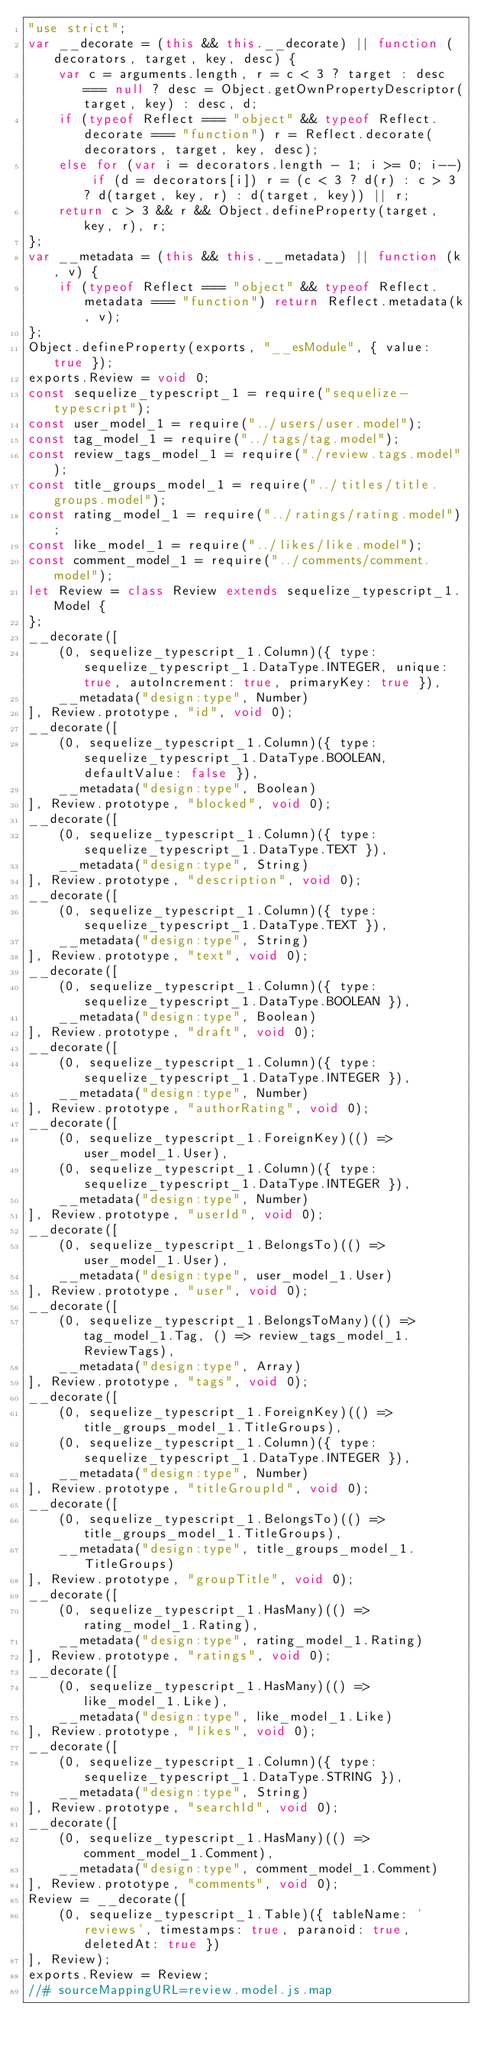<code> <loc_0><loc_0><loc_500><loc_500><_JavaScript_>"use strict";
var __decorate = (this && this.__decorate) || function (decorators, target, key, desc) {
    var c = arguments.length, r = c < 3 ? target : desc === null ? desc = Object.getOwnPropertyDescriptor(target, key) : desc, d;
    if (typeof Reflect === "object" && typeof Reflect.decorate === "function") r = Reflect.decorate(decorators, target, key, desc);
    else for (var i = decorators.length - 1; i >= 0; i--) if (d = decorators[i]) r = (c < 3 ? d(r) : c > 3 ? d(target, key, r) : d(target, key)) || r;
    return c > 3 && r && Object.defineProperty(target, key, r), r;
};
var __metadata = (this && this.__metadata) || function (k, v) {
    if (typeof Reflect === "object" && typeof Reflect.metadata === "function") return Reflect.metadata(k, v);
};
Object.defineProperty(exports, "__esModule", { value: true });
exports.Review = void 0;
const sequelize_typescript_1 = require("sequelize-typescript");
const user_model_1 = require("../users/user.model");
const tag_model_1 = require("../tags/tag.model");
const review_tags_model_1 = require("./review.tags.model");
const title_groups_model_1 = require("../titles/title.groups.model");
const rating_model_1 = require("../ratings/rating.model");
const like_model_1 = require("../likes/like.model");
const comment_model_1 = require("../comments/comment.model");
let Review = class Review extends sequelize_typescript_1.Model {
};
__decorate([
    (0, sequelize_typescript_1.Column)({ type: sequelize_typescript_1.DataType.INTEGER, unique: true, autoIncrement: true, primaryKey: true }),
    __metadata("design:type", Number)
], Review.prototype, "id", void 0);
__decorate([
    (0, sequelize_typescript_1.Column)({ type: sequelize_typescript_1.DataType.BOOLEAN, defaultValue: false }),
    __metadata("design:type", Boolean)
], Review.prototype, "blocked", void 0);
__decorate([
    (0, sequelize_typescript_1.Column)({ type: sequelize_typescript_1.DataType.TEXT }),
    __metadata("design:type", String)
], Review.prototype, "description", void 0);
__decorate([
    (0, sequelize_typescript_1.Column)({ type: sequelize_typescript_1.DataType.TEXT }),
    __metadata("design:type", String)
], Review.prototype, "text", void 0);
__decorate([
    (0, sequelize_typescript_1.Column)({ type: sequelize_typescript_1.DataType.BOOLEAN }),
    __metadata("design:type", Boolean)
], Review.prototype, "draft", void 0);
__decorate([
    (0, sequelize_typescript_1.Column)({ type: sequelize_typescript_1.DataType.INTEGER }),
    __metadata("design:type", Number)
], Review.prototype, "authorRating", void 0);
__decorate([
    (0, sequelize_typescript_1.ForeignKey)(() => user_model_1.User),
    (0, sequelize_typescript_1.Column)({ type: sequelize_typescript_1.DataType.INTEGER }),
    __metadata("design:type", Number)
], Review.prototype, "userId", void 0);
__decorate([
    (0, sequelize_typescript_1.BelongsTo)(() => user_model_1.User),
    __metadata("design:type", user_model_1.User)
], Review.prototype, "user", void 0);
__decorate([
    (0, sequelize_typescript_1.BelongsToMany)(() => tag_model_1.Tag, () => review_tags_model_1.ReviewTags),
    __metadata("design:type", Array)
], Review.prototype, "tags", void 0);
__decorate([
    (0, sequelize_typescript_1.ForeignKey)(() => title_groups_model_1.TitleGroups),
    (0, sequelize_typescript_1.Column)({ type: sequelize_typescript_1.DataType.INTEGER }),
    __metadata("design:type", Number)
], Review.prototype, "titleGroupId", void 0);
__decorate([
    (0, sequelize_typescript_1.BelongsTo)(() => title_groups_model_1.TitleGroups),
    __metadata("design:type", title_groups_model_1.TitleGroups)
], Review.prototype, "groupTitle", void 0);
__decorate([
    (0, sequelize_typescript_1.HasMany)(() => rating_model_1.Rating),
    __metadata("design:type", rating_model_1.Rating)
], Review.prototype, "ratings", void 0);
__decorate([
    (0, sequelize_typescript_1.HasMany)(() => like_model_1.Like),
    __metadata("design:type", like_model_1.Like)
], Review.prototype, "likes", void 0);
__decorate([
    (0, sequelize_typescript_1.Column)({ type: sequelize_typescript_1.DataType.STRING }),
    __metadata("design:type", String)
], Review.prototype, "searchId", void 0);
__decorate([
    (0, sequelize_typescript_1.HasMany)(() => comment_model_1.Comment),
    __metadata("design:type", comment_model_1.Comment)
], Review.prototype, "comments", void 0);
Review = __decorate([
    (0, sequelize_typescript_1.Table)({ tableName: 'reviews', timestamps: true, paranoid: true, deletedAt: true })
], Review);
exports.Review = Review;
//# sourceMappingURL=review.model.js.map</code> 